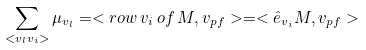Convert formula to latex. <formula><loc_0><loc_0><loc_500><loc_500>\sum _ { < v _ { l } v _ { i } > } \mu _ { v _ { l } } = < r o w \, v _ { i } \, o f \, M , v _ { p f } > = < { \hat { e } } _ { v _ { i } } M , v _ { p f } ></formula> 